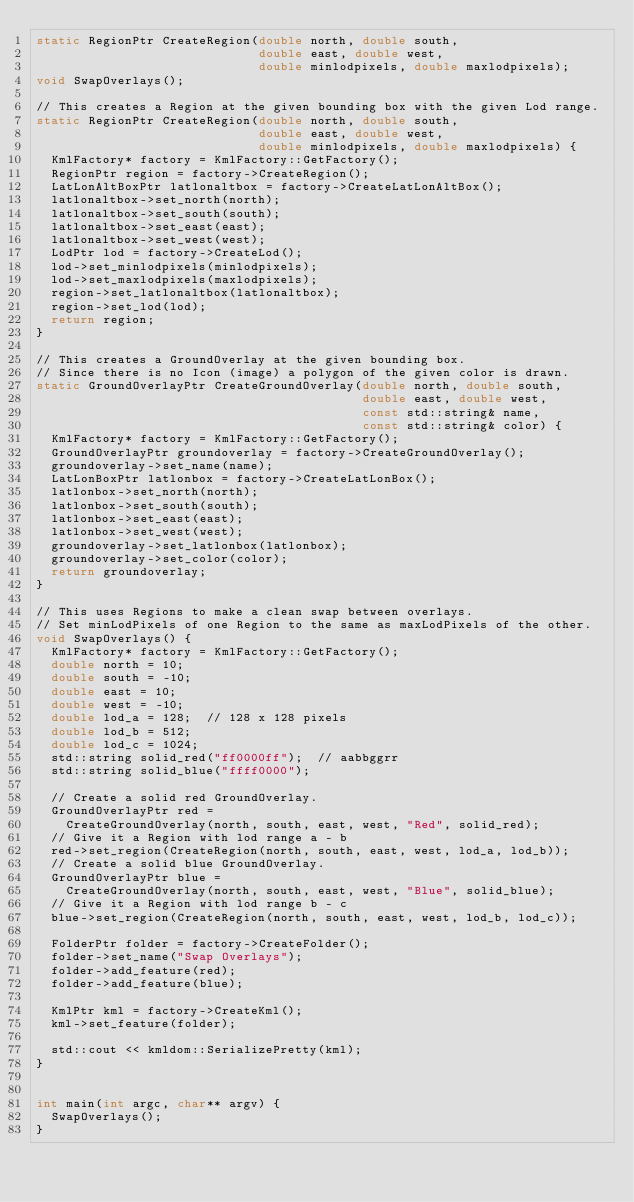Convert code to text. <code><loc_0><loc_0><loc_500><loc_500><_C++_>static RegionPtr CreateRegion(double north, double south,
                              double east, double west,
                              double minlodpixels, double maxlodpixels);
void SwapOverlays();

// This creates a Region at the given bounding box with the given Lod range.
static RegionPtr CreateRegion(double north, double south,
                              double east, double west,
                              double minlodpixels, double maxlodpixels) {
  KmlFactory* factory = KmlFactory::GetFactory();
  RegionPtr region = factory->CreateRegion();
  LatLonAltBoxPtr latlonaltbox = factory->CreateLatLonAltBox();
  latlonaltbox->set_north(north);
  latlonaltbox->set_south(south);
  latlonaltbox->set_east(east);
  latlonaltbox->set_west(west);
  LodPtr lod = factory->CreateLod();
  lod->set_minlodpixels(minlodpixels);
  lod->set_maxlodpixels(maxlodpixels);
  region->set_latlonaltbox(latlonaltbox);
  region->set_lod(lod);
  return region;
}

// This creates a GroundOverlay at the given bounding box.
// Since there is no Icon (image) a polygon of the given color is drawn.
static GroundOverlayPtr CreateGroundOverlay(double north, double south,
                                            double east, double west,
                                            const std::string& name,
                                            const std::string& color) {
  KmlFactory* factory = KmlFactory::GetFactory();
  GroundOverlayPtr groundoverlay = factory->CreateGroundOverlay();
  groundoverlay->set_name(name);
  LatLonBoxPtr latlonbox = factory->CreateLatLonBox();
  latlonbox->set_north(north);
  latlonbox->set_south(south);
  latlonbox->set_east(east);
  latlonbox->set_west(west);
  groundoverlay->set_latlonbox(latlonbox);
  groundoverlay->set_color(color);
  return groundoverlay;
}

// This uses Regions to make a clean swap between overlays.
// Set minLodPixels of one Region to the same as maxLodPixels of the other.
void SwapOverlays() {
  KmlFactory* factory = KmlFactory::GetFactory();
  double north = 10;
  double south = -10;
  double east = 10;
  double west = -10;
  double lod_a = 128;  // 128 x 128 pixels
  double lod_b = 512;
  double lod_c = 1024;
  std::string solid_red("ff0000ff");  // aabbggrr
  std::string solid_blue("ffff0000");

  // Create a solid red GroundOverlay.
  GroundOverlayPtr red =
    CreateGroundOverlay(north, south, east, west, "Red", solid_red);
  // Give it a Region with lod range a - b
  red->set_region(CreateRegion(north, south, east, west, lod_a, lod_b));
  // Create a solid blue GroundOverlay.
  GroundOverlayPtr blue =
    CreateGroundOverlay(north, south, east, west, "Blue", solid_blue);
  // Give it a Region with lod range b - c
  blue->set_region(CreateRegion(north, south, east, west, lod_b, lod_c));

  FolderPtr folder = factory->CreateFolder();
  folder->set_name("Swap Overlays");
  folder->add_feature(red);
  folder->add_feature(blue);

  KmlPtr kml = factory->CreateKml();
  kml->set_feature(folder);

  std::cout << kmldom::SerializePretty(kml);
}


int main(int argc, char** argv) {
  SwapOverlays();
}
</code> 